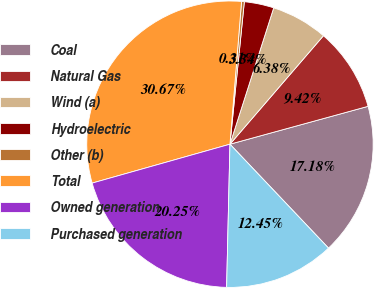Convert chart to OTSL. <chart><loc_0><loc_0><loc_500><loc_500><pie_chart><fcel>Coal<fcel>Natural Gas<fcel>Wind (a)<fcel>Hydroelectric<fcel>Other (b)<fcel>Total<fcel>Owned generation<fcel>Purchased generation<nl><fcel>17.18%<fcel>9.42%<fcel>6.38%<fcel>3.34%<fcel>0.31%<fcel>30.67%<fcel>20.25%<fcel>12.45%<nl></chart> 